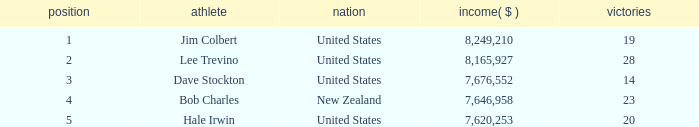How much have players earned with 14 wins ranked below 3? 0.0. 